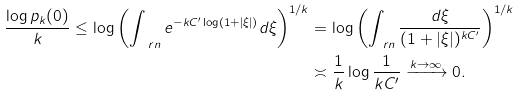Convert formula to latex. <formula><loc_0><loc_0><loc_500><loc_500>\frac { \log p _ { k } ( 0 ) } { k } \leq \log \left ( \int _ { \ r n } e ^ { - k C ^ { \prime } \log ( 1 + | \xi | ) } d \xi \right ) ^ { 1 / k } & = \log \left ( \int _ { \ r n } \frac { d \xi } { ( 1 + | \xi | ) ^ { k C ^ { \prime } } } \right ) ^ { 1 / k } \\ & \asymp \frac { 1 } { k } \log \frac { 1 } { k C ^ { \prime } } \xrightarrow { k \to \infty } 0 .</formula> 